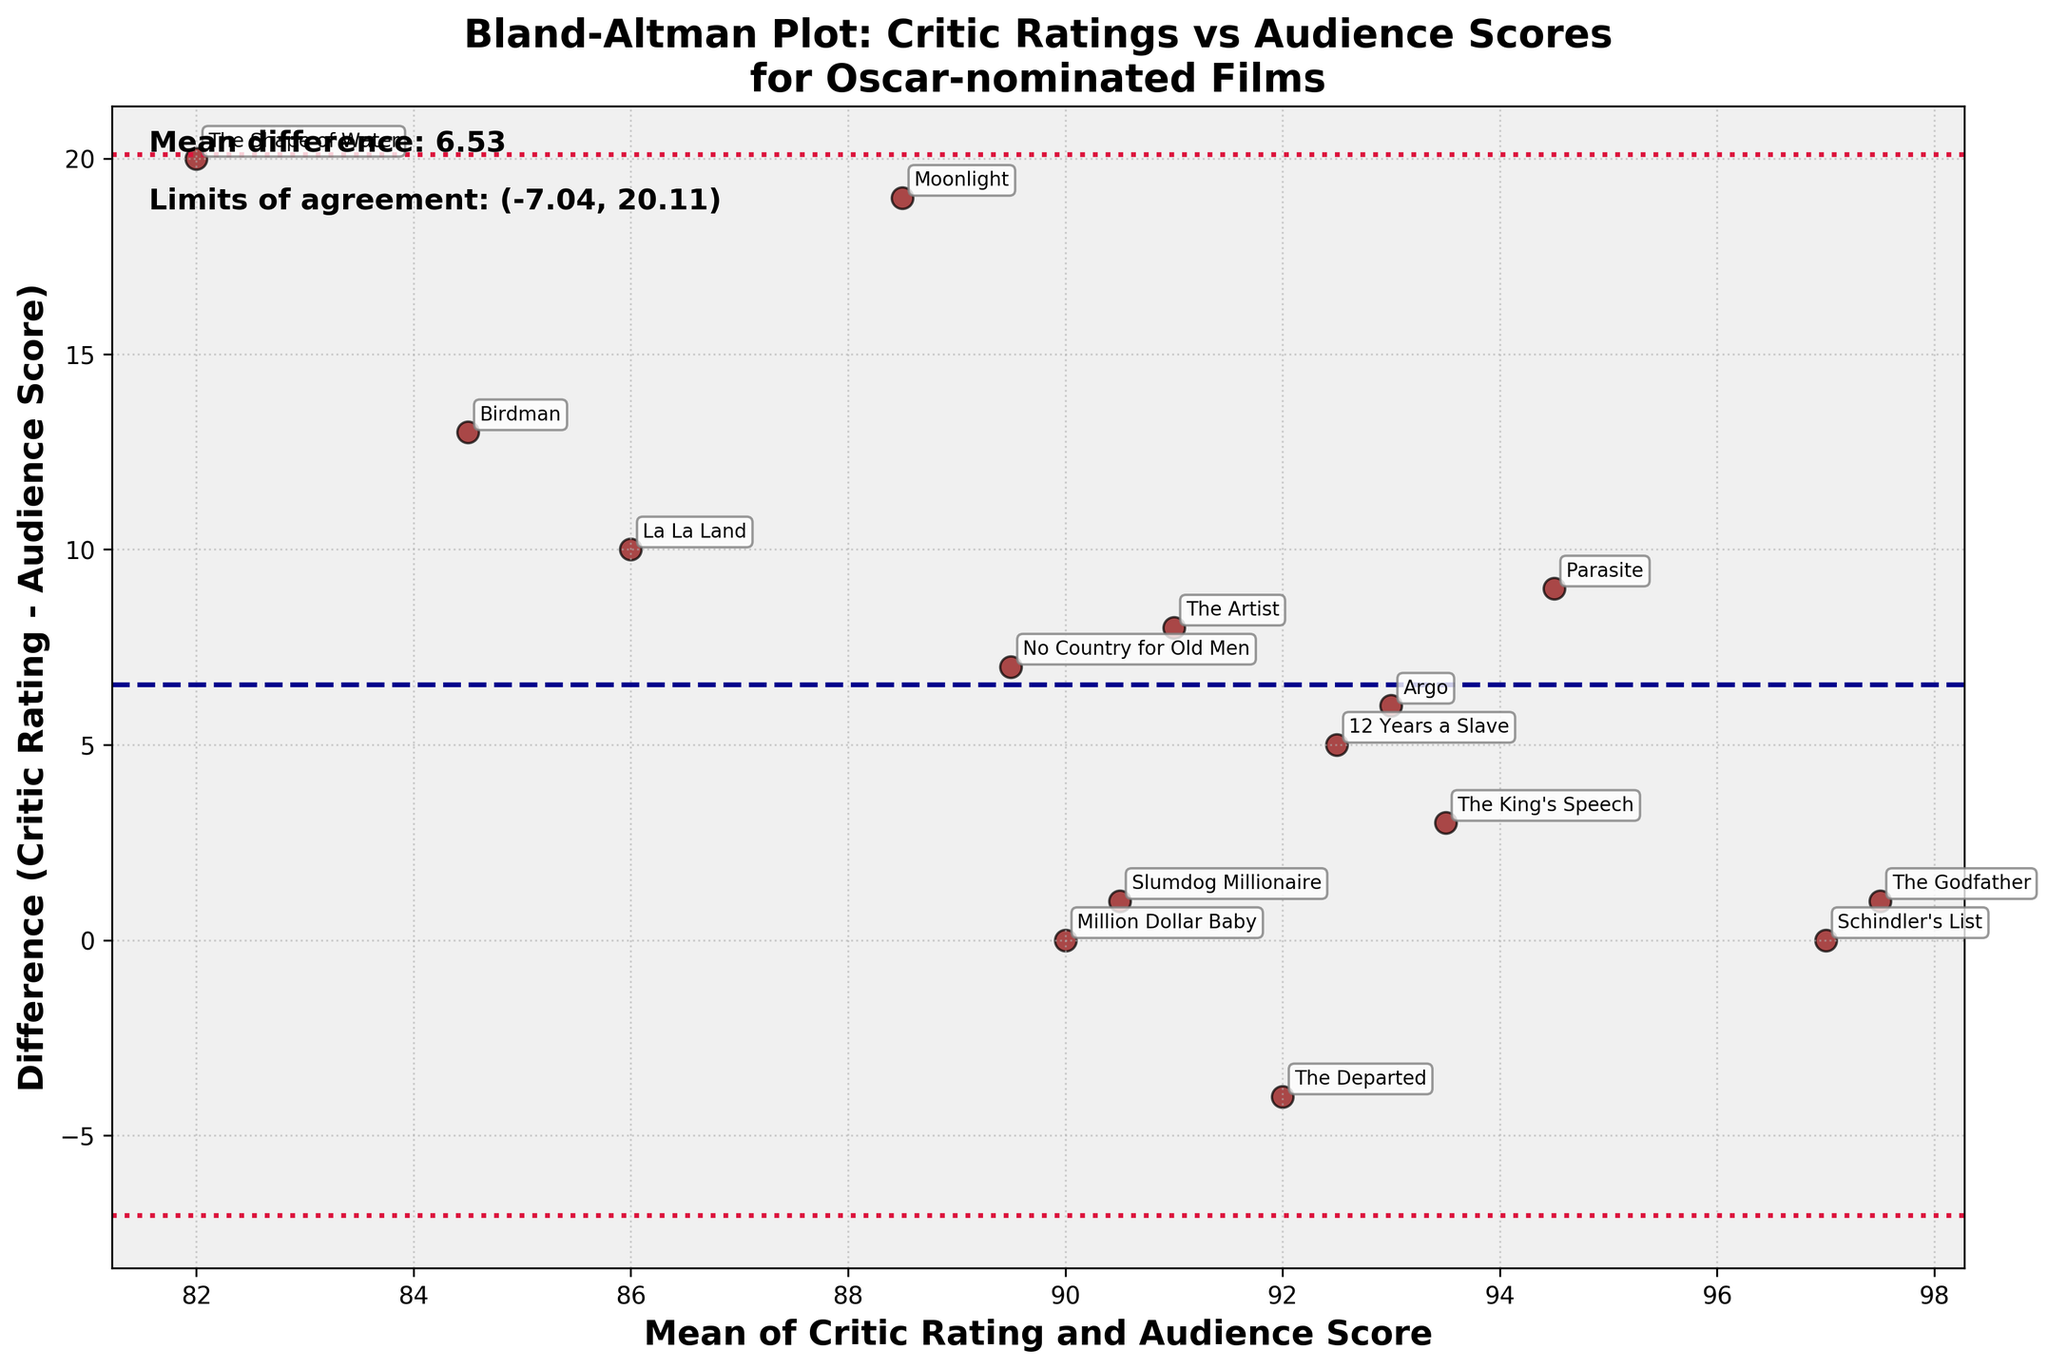What is the title of the plot? The title is typically situated at the top of the figure. Here, it reads "Bland-Altman Plot: Critic Ratings vs Audience Scores for Oscar-nominated Films".
Answer: Bland-Altman Plot: Critic Ratings vs Audience Scores for Oscar-nominated Films What are the labels on the x and y axes? The labels for the axes are found next to the respective axes. The x-axis label is "Mean of Critic Rating and Audience Score" and the y-axis label is "Difference (Critic Rating - Audience Score)".
Answer: Mean of Critic Rating and Audience Score (x-axis), Difference (Critic Rating - Audience Score) (y-axis) How many data points are plotted in the figure? Each data point corresponds to an Oscar-nominated film, represented by a marker in the plot. By counting these markers, we find that there are 15 data points.
Answer: 15 What is the mean difference between critic ratings and audience scores? The mean difference is presented as text usually located somewhere within the plot area. It shows the average value of the differences between critic ratings and audience scores. In this figure, it's noted as "Mean difference: 4.27".
Answer: 4.27 Which film has the highest difference between critic ratings and audience scores? Look for the marker with the highest vertical distance from the x-axis. The label of this marker, pointing to the highest difference, reveals the film's title. In this case, "Moonlight" has the highest positive difference.
Answer: Moonlight What are the limits of agreement? The limits of agreement are noted in the plot, often near the text indicating the mean difference. Two horizontal lines represent these limits, and the values are presented as "Limits of agreement: (-5.78, 14.32)".
Answer: (-5.78, 14.32) Which film has the mean value closest to the maximum value on the x-axis? The mean value is plotted on the x-axis, look for the film label closest to the maximum value on the x-axis. In this figure, "Parasite" is closest to the maximum value on the x-axis.
Answer: Parasite Which films have a critic rating equal to the audience score? On a Bland-Altman plot, a film with equal critic rating and audience score will have a difference of zero. Examine where the difference equals zero and read the corresponding film labels. Films like "The Godfather" and "Schindler's List" meet this criterion.
Answer: The Godfather, Schindler's List What is the overall trend or pattern observed in the differences between critic ratings and audience scores? A Bland-Altman plot typically reveals any systematic differences between two measurements. Most points are above the x-axis indicating critic ratings are generally higher than audience scores.
Answer: Critics rate movies higher on average Does any film fall outside the limits of agreement? If yes, which one(s)? Limits of agreement are visualized as two horizontal lines. Locate any data points outside these limits. Here, no data points fall outside the limits of agreement.
Answer: No 